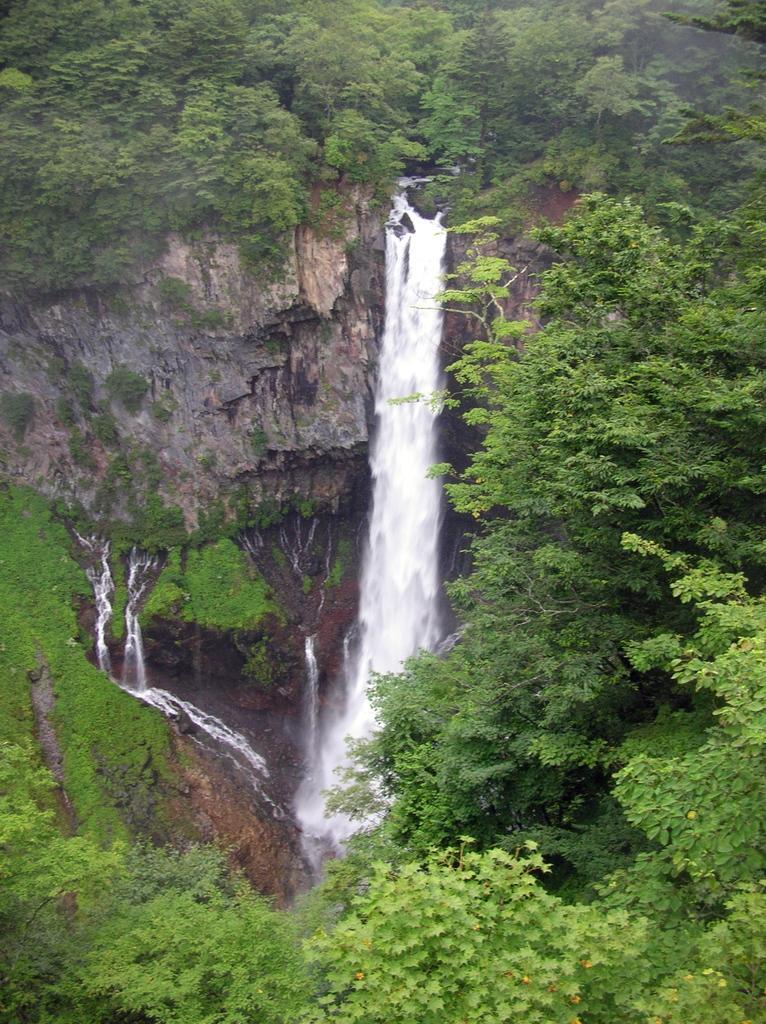Can you describe this image briefly? In this image we can see a waterfall. And we can see the surrounding trees. 